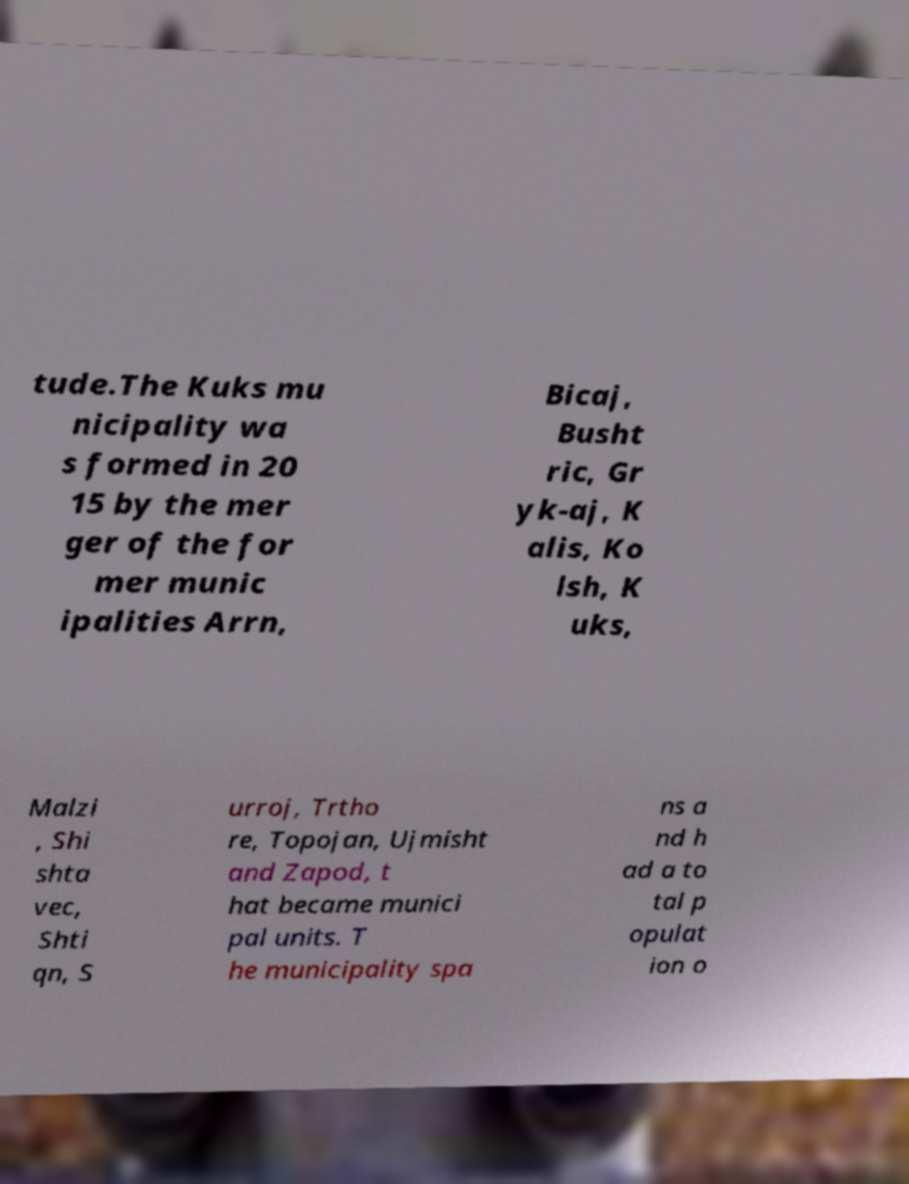Please read and relay the text visible in this image. What does it say? tude.The Kuks mu nicipality wa s formed in 20 15 by the mer ger of the for mer munic ipalities Arrn, Bicaj, Busht ric, Gr yk-aj, K alis, Ko lsh, K uks, Malzi , Shi shta vec, Shti qn, S urroj, Trtho re, Topojan, Ujmisht and Zapod, t hat became munici pal units. T he municipality spa ns a nd h ad a to tal p opulat ion o 